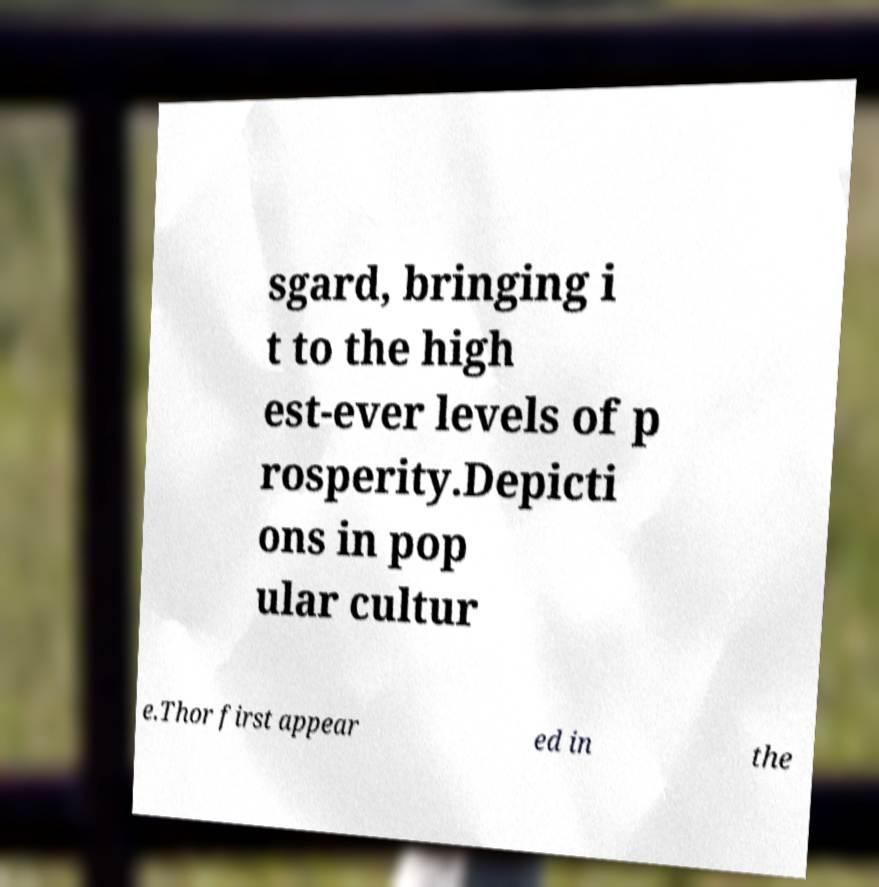What messages or text are displayed in this image? I need them in a readable, typed format. sgard, bringing i t to the high est-ever levels of p rosperity.Depicti ons in pop ular cultur e.Thor first appear ed in the 